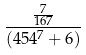Convert formula to latex. <formula><loc_0><loc_0><loc_500><loc_500>\frac { \frac { 7 } { 1 6 7 } } { ( 4 5 4 ^ { 7 } + 6 ) }</formula> 